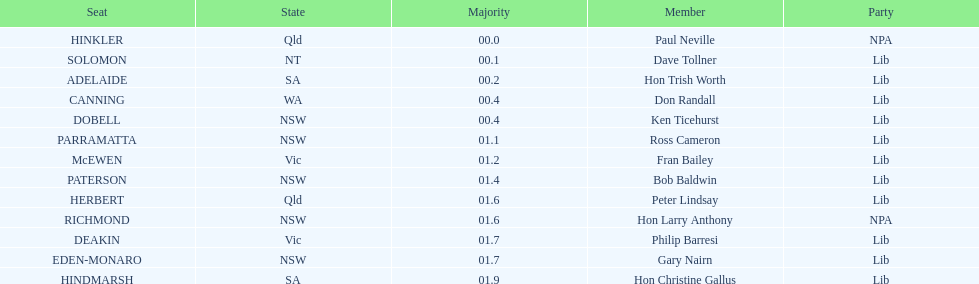Can you provide the count of seats from nsw? 5. 